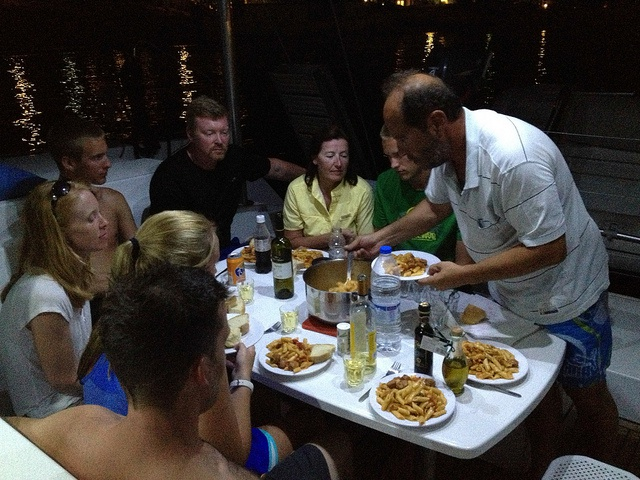Describe the objects in this image and their specific colors. I can see dining table in black, lavender, gray, and darkgray tones, people in black, gray, white, and darkgray tones, people in black, gray, brown, and maroon tones, people in black, gray, and maroon tones, and people in black, maroon, brown, and gray tones in this image. 